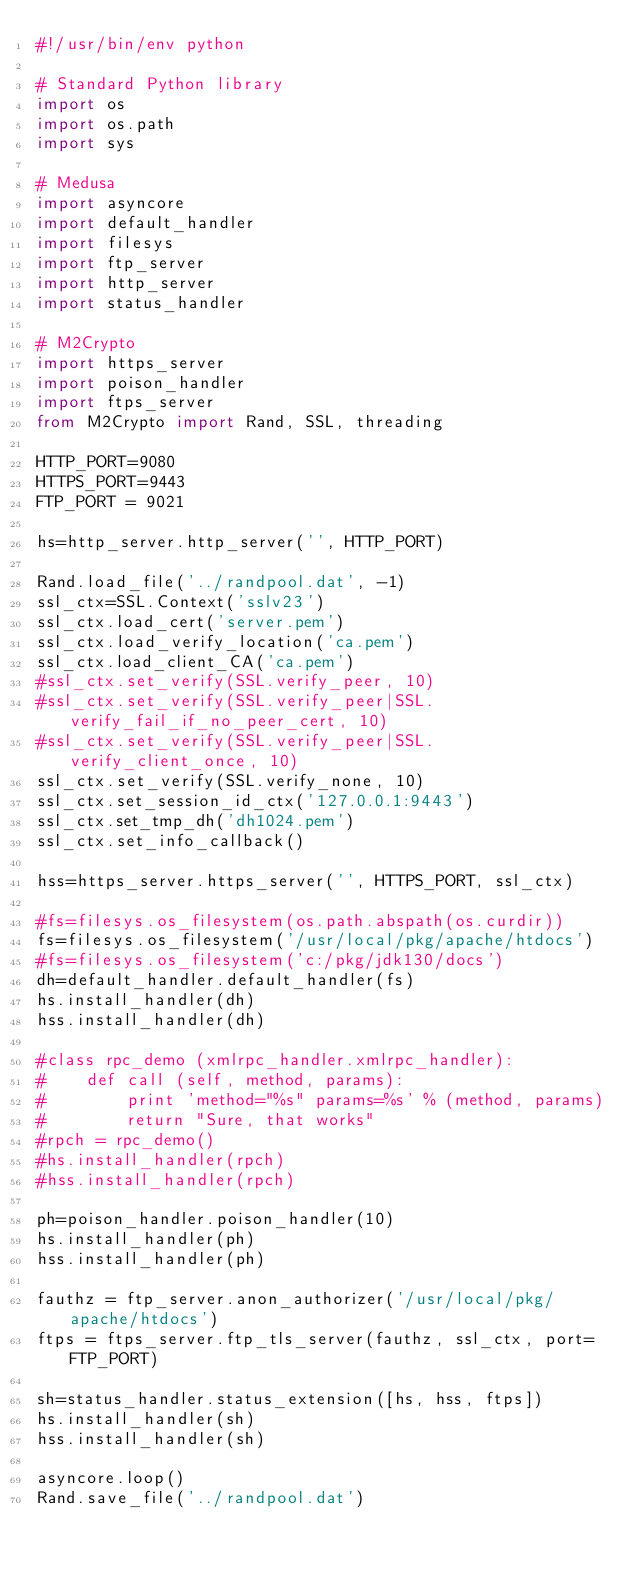Convert code to text. <code><loc_0><loc_0><loc_500><loc_500><_Python_>#!/usr/bin/env python

# Standard Python library
import os
import os.path
import sys

# Medusa 
import asyncore
import default_handler
import filesys
import ftp_server
import http_server
import status_handler

# M2Crypto
import https_server
import poison_handler
import ftps_server
from M2Crypto import Rand, SSL, threading

HTTP_PORT=9080
HTTPS_PORT=9443
FTP_PORT = 9021

hs=http_server.http_server('', HTTP_PORT)

Rand.load_file('../randpool.dat', -1) 
ssl_ctx=SSL.Context('sslv23')
ssl_ctx.load_cert('server.pem')
ssl_ctx.load_verify_location('ca.pem')
ssl_ctx.load_client_CA('ca.pem')
#ssl_ctx.set_verify(SSL.verify_peer, 10)
#ssl_ctx.set_verify(SSL.verify_peer|SSL.verify_fail_if_no_peer_cert, 10)
#ssl_ctx.set_verify(SSL.verify_peer|SSL.verify_client_once, 10)
ssl_ctx.set_verify(SSL.verify_none, 10)
ssl_ctx.set_session_id_ctx('127.0.0.1:9443')
ssl_ctx.set_tmp_dh('dh1024.pem')
ssl_ctx.set_info_callback()

hss=https_server.https_server('', HTTPS_PORT, ssl_ctx)

#fs=filesys.os_filesystem(os.path.abspath(os.curdir))
fs=filesys.os_filesystem('/usr/local/pkg/apache/htdocs')
#fs=filesys.os_filesystem('c:/pkg/jdk130/docs')
dh=default_handler.default_handler(fs)
hs.install_handler(dh)
hss.install_handler(dh)

#class rpc_demo (xmlrpc_handler.xmlrpc_handler):
#    def call (self, method, params):
#        print 'method="%s" params=%s' % (method, params)
#        return "Sure, that works"
#rpch = rpc_demo()
#hs.install_handler(rpch)
#hss.install_handler(rpch)

ph=poison_handler.poison_handler(10)
hs.install_handler(ph)
hss.install_handler(ph)

fauthz = ftp_server.anon_authorizer('/usr/local/pkg/apache/htdocs')
ftps = ftps_server.ftp_tls_server(fauthz, ssl_ctx, port=FTP_PORT)

sh=status_handler.status_extension([hs, hss, ftps])
hs.install_handler(sh)
hss.install_handler(sh)

asyncore.loop()
Rand.save_file('../randpool.dat')

</code> 